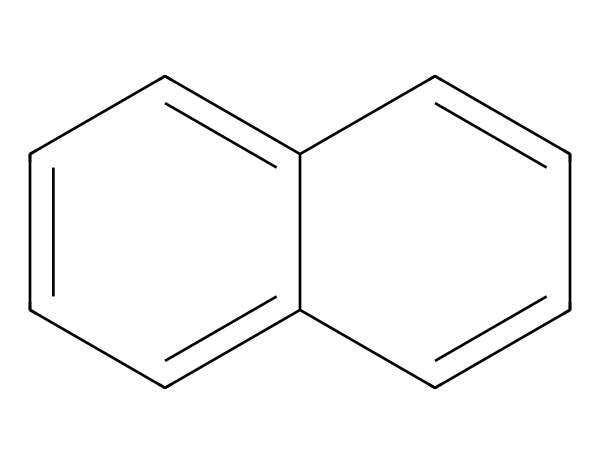How many carbon atoms are in the structure? The SMILES representation indicates a total of eight carbon atoms are present, as each 'C' symbolizes a carbon atom.
Answer: eight What is the molecular formula for the compound? Count the number of carbon (C) and hydrogen (H) atoms; there are eight carbons and six hydrogens, leading to the formula C8H6.
Answer: C8H6 Does this compound contain any functional groups? The structure lacks distinct functional groups like alcohols, amines, or carboxylic acids, typical in organic compounds. It primarily consists of carbon and hydrogen, hence no functional groups.
Answer: no What type of hybridization do the carbon atoms exhibit? The structure is mainly composed of sp2 hybridized carbon atoms due to the presence of double bonds (indicated by =), contributing to planar geometry.
Answer: sp2 Is this compound aromatic? The chemical structure features alternating double bonds in a cyclic arrangement (characteristic of benzene rings), making it aromatic.
Answer: yes What is the significance of this compound in lightweight vehicle construction? Its stable planar structure, lightweight properties, and high tensile strength contribute to materials utilized for enhancing vehicle performance and efficiency.
Answer: high strength How might this compound interact in a coordination compound context? As it can serve as a ligand with potential coordination properties due to π electrons in the aromatic system, it may stabilize metal cations in coordination complexes.
Answer: forms ligands 